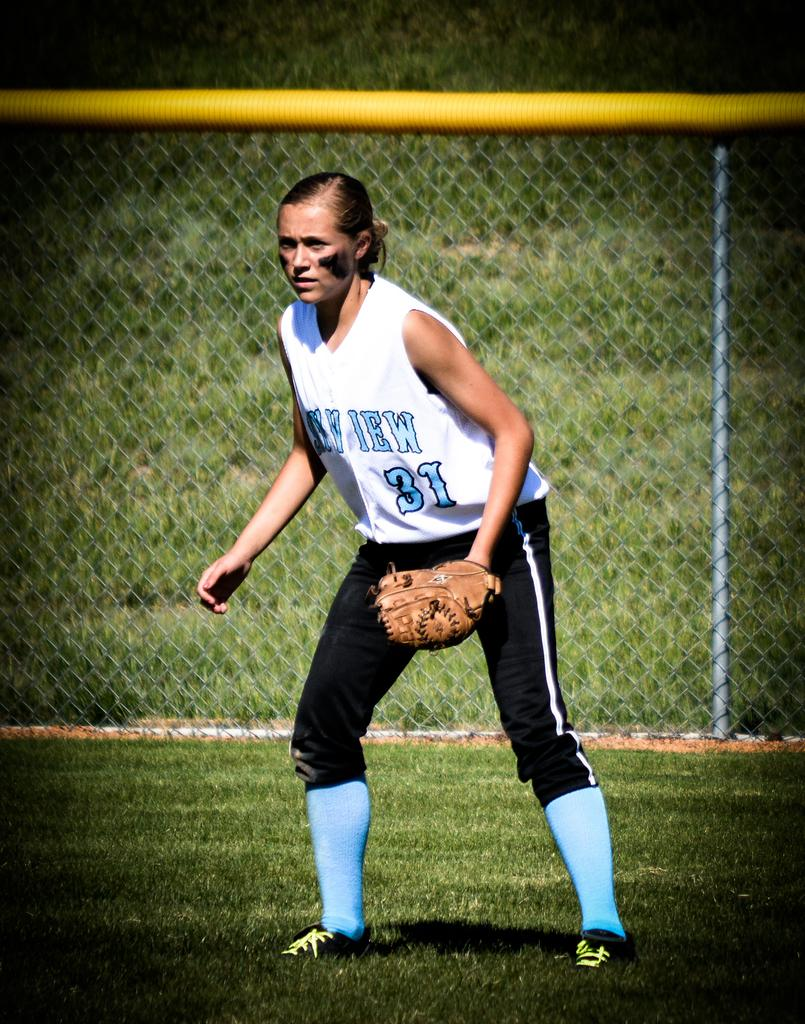Provide a one-sentence caption for the provided image. A baseball player with the team number 31 is positioned in the outfield. 